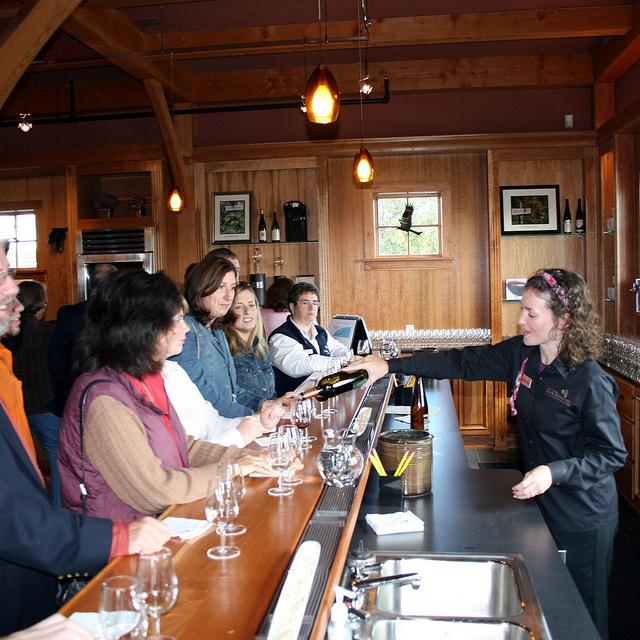Describe the objects in this image and their specific colors. I can see people in black, gray, navy, and blue tones, people in black, lightpink, brown, and darkgray tones, people in black, navy, darkblue, and red tones, sink in black, white, darkgray, gray, and lightblue tones, and people in black, gray, and lightpink tones in this image. 